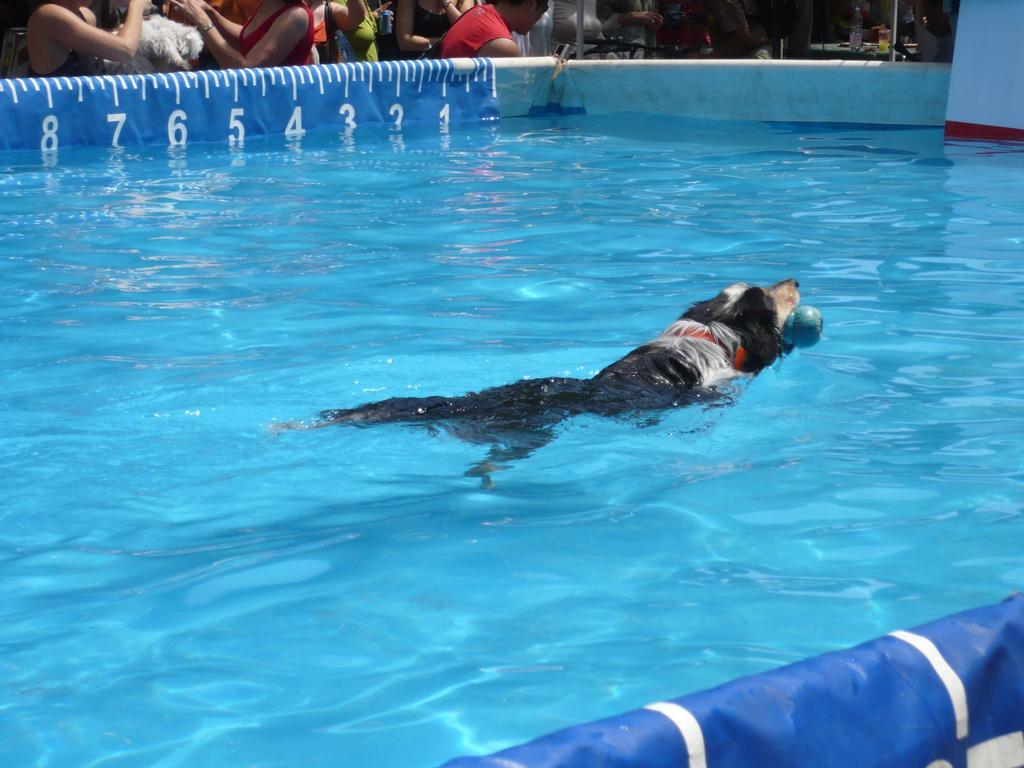What animal is present in the image? There is a dog in the image. What is the dog doing in the image? The dog is swimming in a pool. Is the dog holding anything while swimming? Yes, the dog is holding an object. Who else can be seen in the image besides the dog? There are people visible at the top of the image. What else can be seen at the top of the image? There is a banner and other objects visible. What disease is the dog trying to cure by swimming in the pool? There is no indication in the image that the dog is trying to cure a disease by swimming in the pool. 